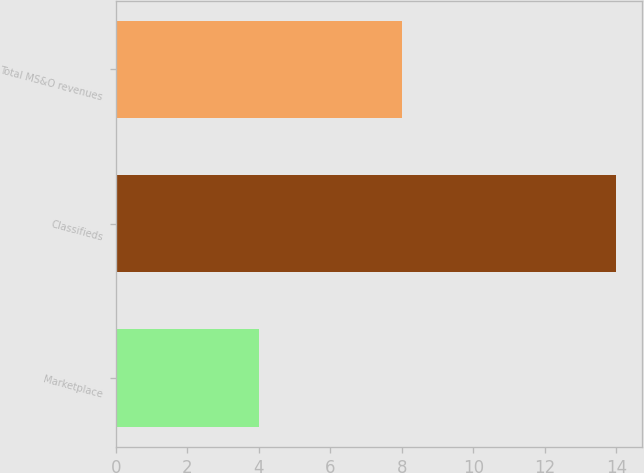Convert chart to OTSL. <chart><loc_0><loc_0><loc_500><loc_500><bar_chart><fcel>Marketplace<fcel>Classifieds<fcel>Total MS&O revenues<nl><fcel>4<fcel>14<fcel>8<nl></chart> 